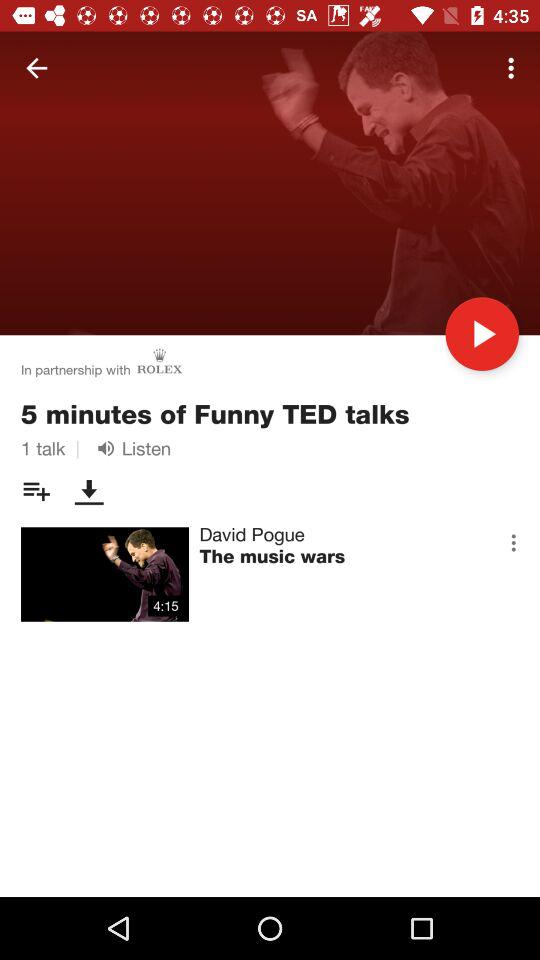How many TED talks are there? There is 1 TED talk. 